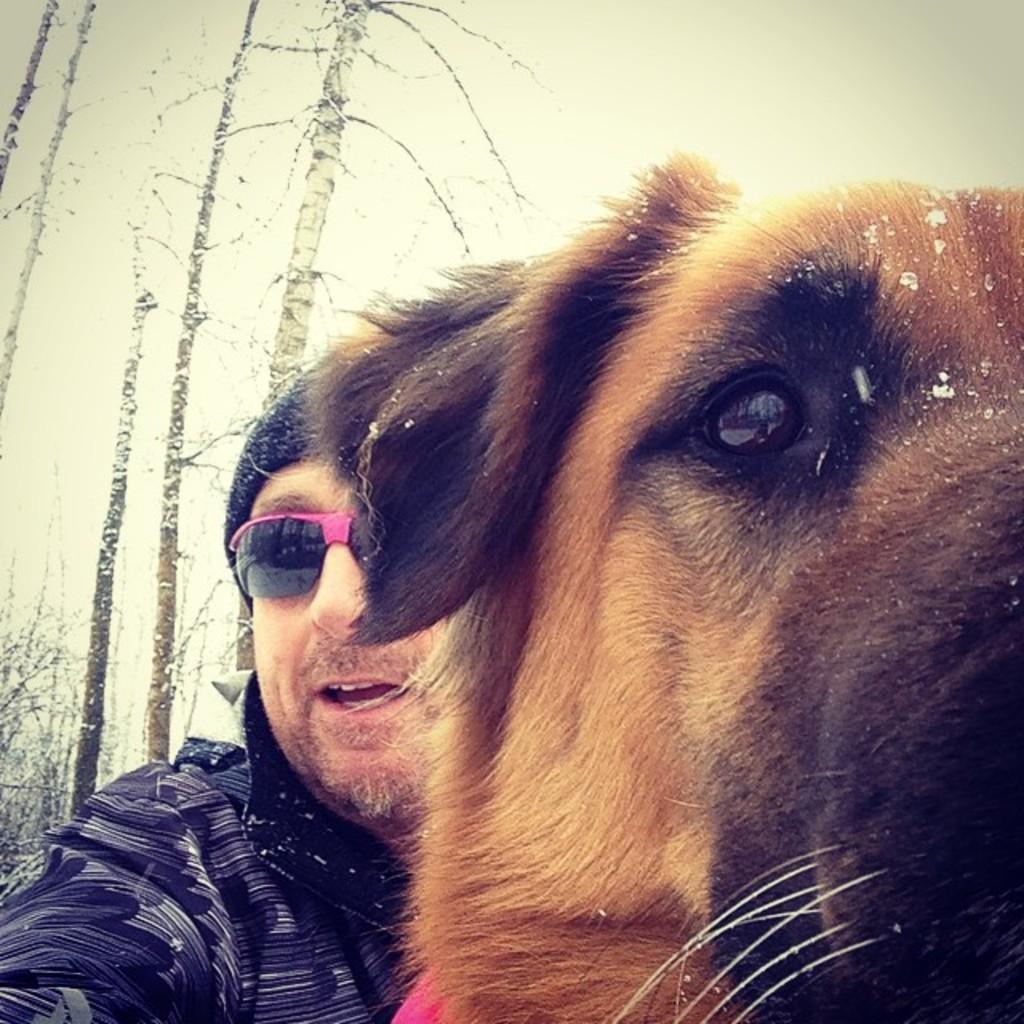How would you summarize this image in a sentence or two? In the picture we can see a man holding a dog which is brown in color, a man is wearing a blue T-shirt with black glasses with pink frame and cap. In the background we can see a tall trees with snow and sky. 